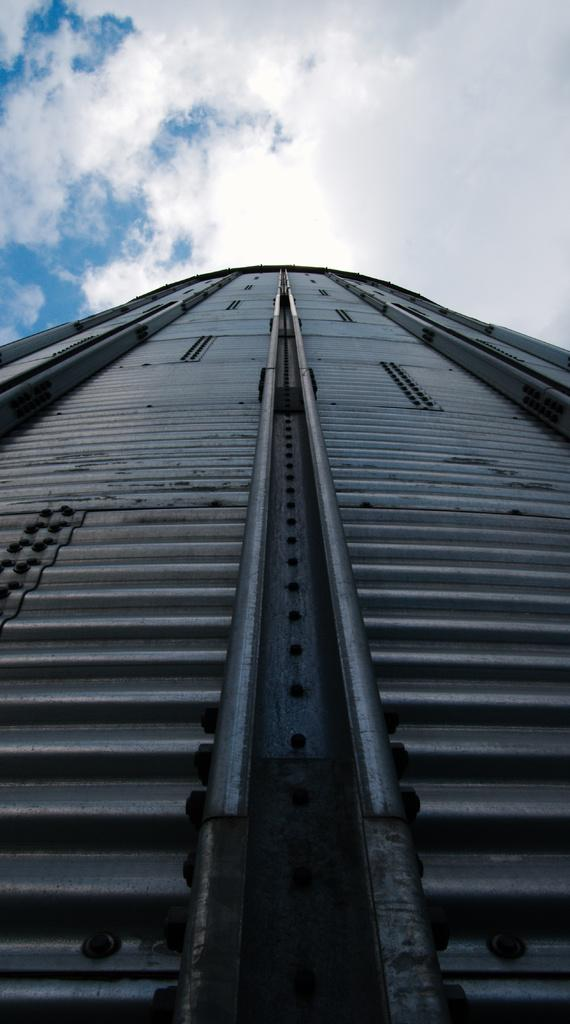What is the main subject of the image? The main subject of the image is an under-construction bridge. What is the condition of the sky in the image? The sky is clouded in the image. Can you tell me how many receipts are visible on the bridge in the image? There are no receipts visible on the bridge in the image. What type of hot item is being held by the hands in the image? There are no hands or hot items present in the image. 